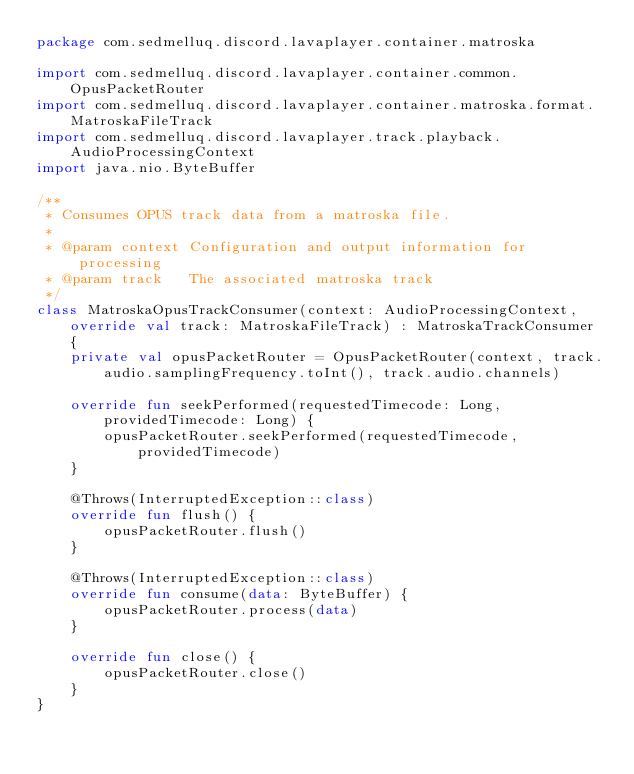<code> <loc_0><loc_0><loc_500><loc_500><_Kotlin_>package com.sedmelluq.discord.lavaplayer.container.matroska

import com.sedmelluq.discord.lavaplayer.container.common.OpusPacketRouter
import com.sedmelluq.discord.lavaplayer.container.matroska.format.MatroskaFileTrack
import com.sedmelluq.discord.lavaplayer.track.playback.AudioProcessingContext
import java.nio.ByteBuffer

/**
 * Consumes OPUS track data from a matroska file.
 *
 * @param context Configuration and output information for processing
 * @param track   The associated matroska track
 */
class MatroskaOpusTrackConsumer(context: AudioProcessingContext, override val track: MatroskaFileTrack) : MatroskaTrackConsumer {
    private val opusPacketRouter = OpusPacketRouter(context, track.audio.samplingFrequency.toInt(), track.audio.channels)

    override fun seekPerformed(requestedTimecode: Long, providedTimecode: Long) {
        opusPacketRouter.seekPerformed(requestedTimecode, providedTimecode)
    }

    @Throws(InterruptedException::class)
    override fun flush() {
        opusPacketRouter.flush()
    }

    @Throws(InterruptedException::class)
    override fun consume(data: ByteBuffer) {
        opusPacketRouter.process(data)
    }

    override fun close() {
        opusPacketRouter.close()
    }
}
</code> 